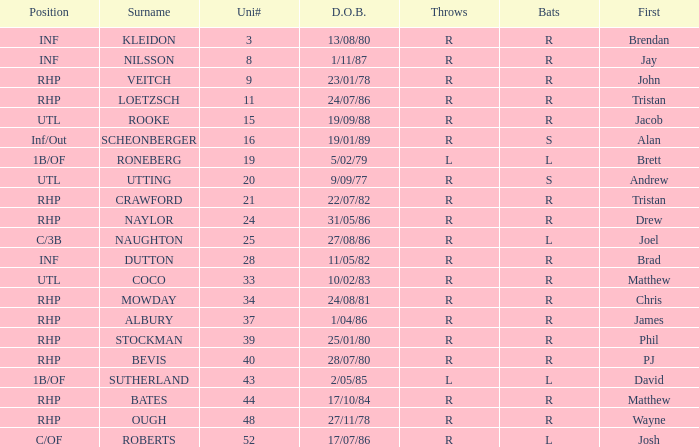How many Uni numbers have Bats of s, and a Position of utl? 1.0. 